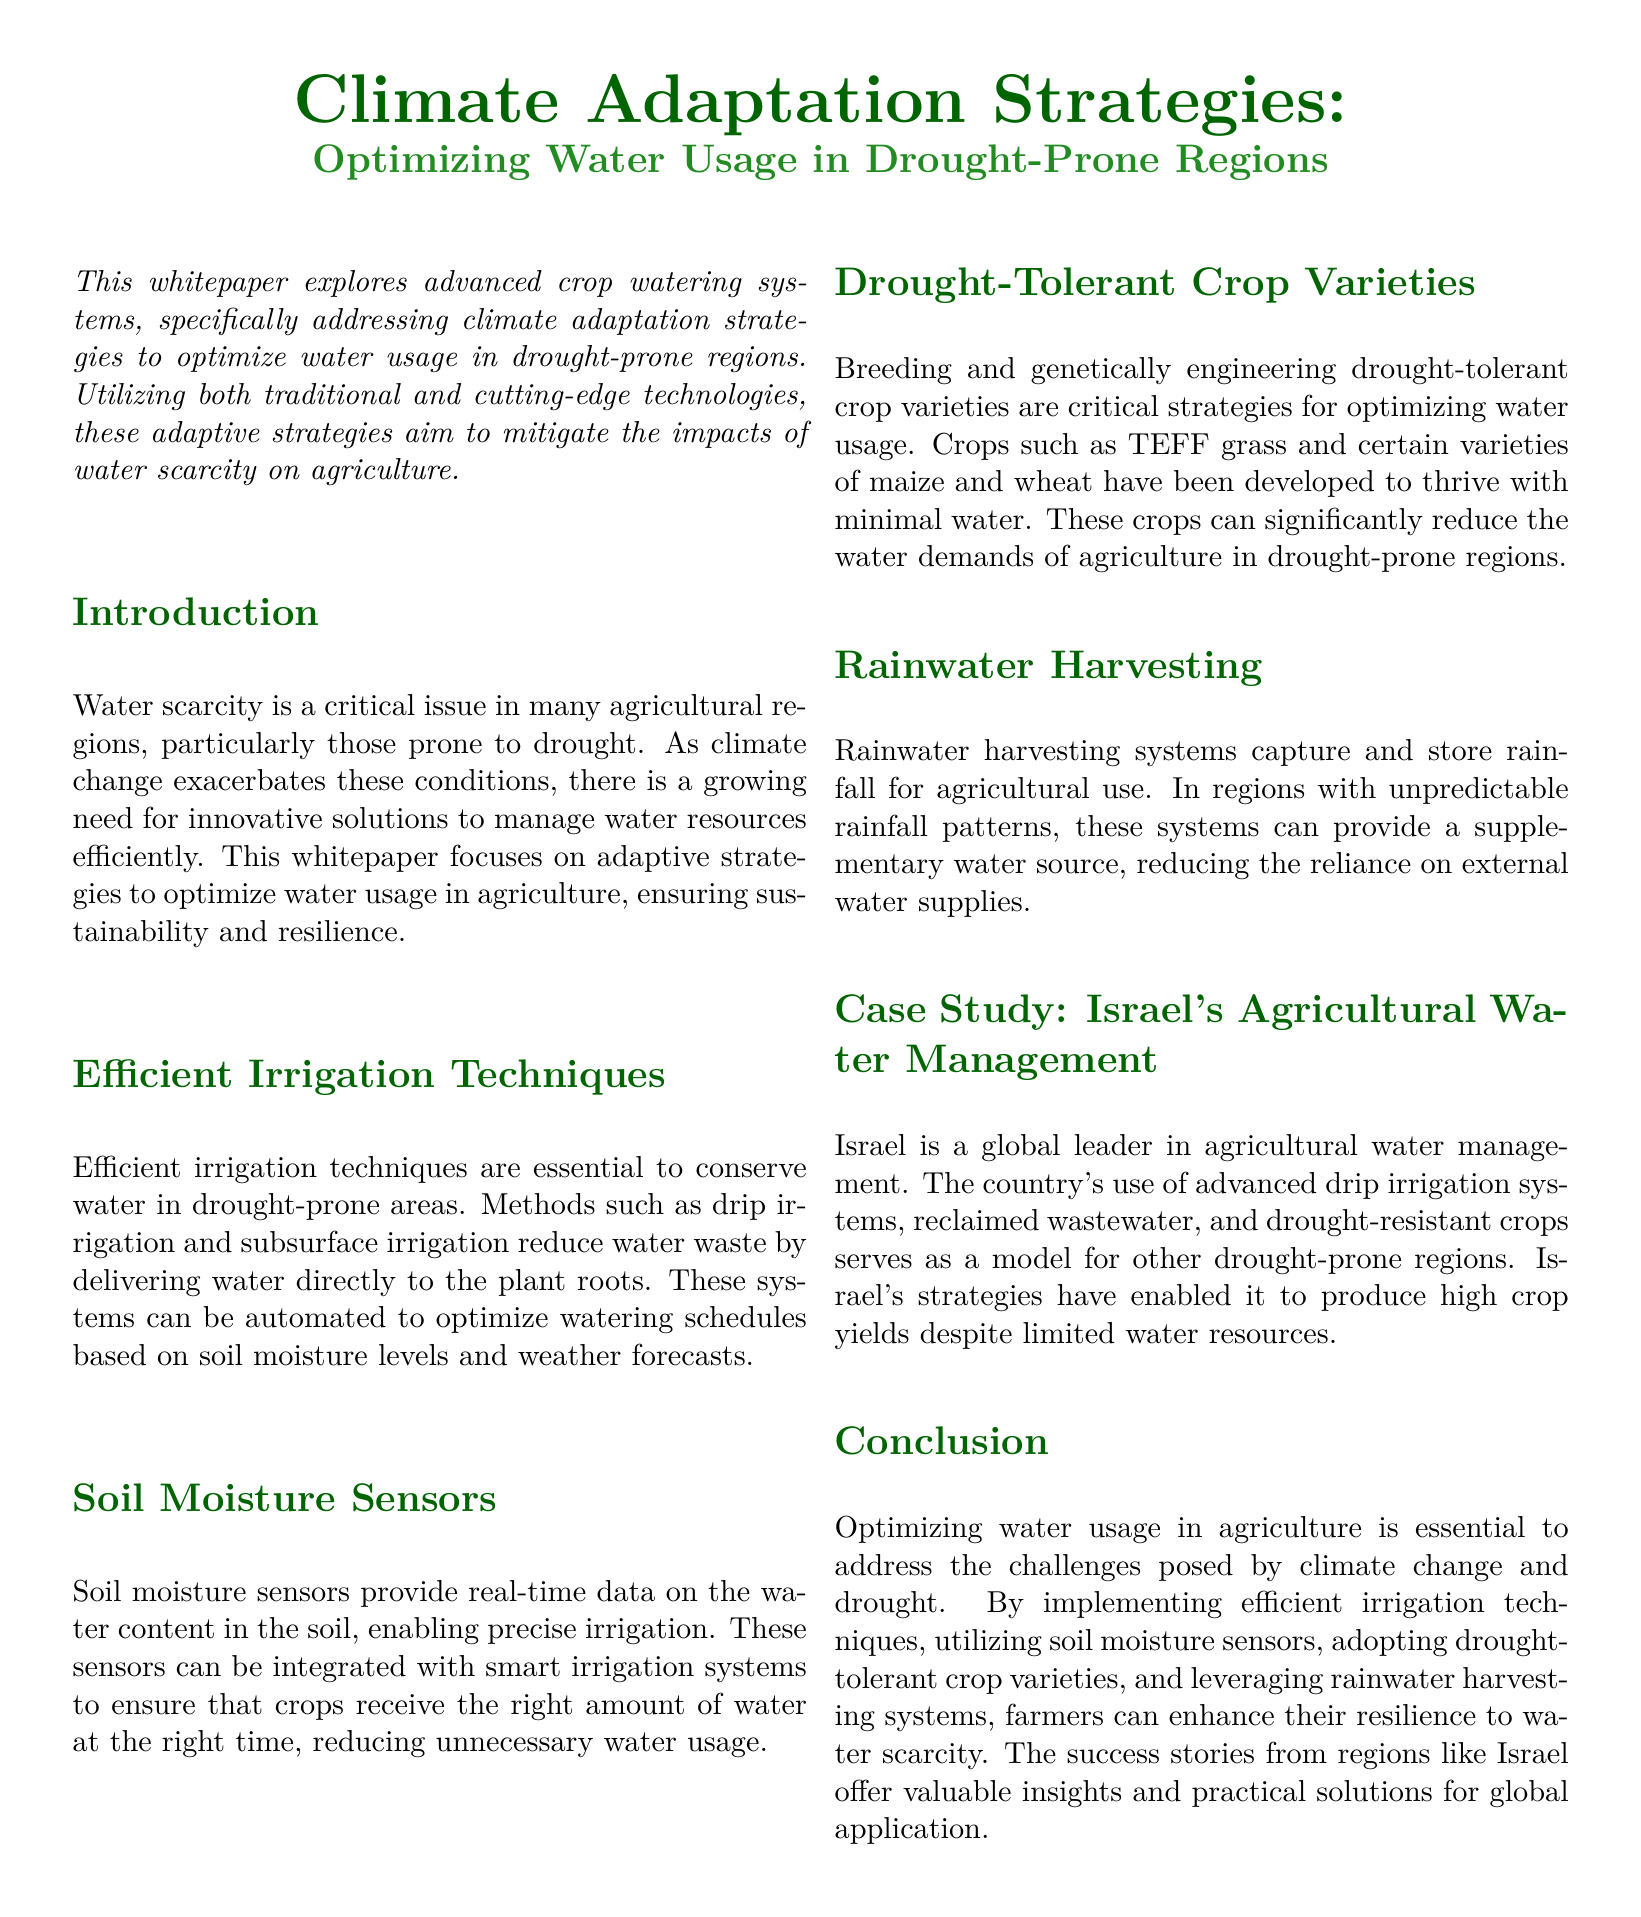What is the main focus of the whitepaper? The whitepaper explores advanced crop watering systems and strategies to optimize water usage in drought-prone regions.
Answer: Advanced crop watering systems What is one method mentioned for efficient irrigation? The document lists drip irrigation and subsurface irrigation as efficient irrigation techniques.
Answer: Drip irrigation What role do soil moisture sensors play? Soil moisture sensors provide real-time data on water content in the soil for precise irrigation.
Answer: Precise irrigation Name a drought-tolerant crop mentioned. TEFF grass is listed as a drought-tolerant crop variety developed for minimal water needs.
Answer: TEFF grass Which country is highlighted as a leader in agricultural water management? The case study features Israel as a global leader in agricultural water management practices.
Answer: Israel What is a supplementary water source mentioned for agricultural use? Rainwater harvesting systems are noted as a supplementary water source in drought-prone areas.
Answer: Rainwater harvesting How do advanced irrigation systems benefit agriculture? They reduce water waste by delivering water directly to plant roots via automation based on specific conditions.
Answer: Reduce water waste What are the two aspects combined to optimize irrigation schedules? Smart irrigation systems utilize soil moisture levels and weather forecasts to optimize irrigation.
Answer: Soil moisture levels and weather forecasts What is the purpose of rainwater harvesting systems? They are designed to capture and store rainfall, providing a supplementary source of water.
Answer: Capture and store rainfall 